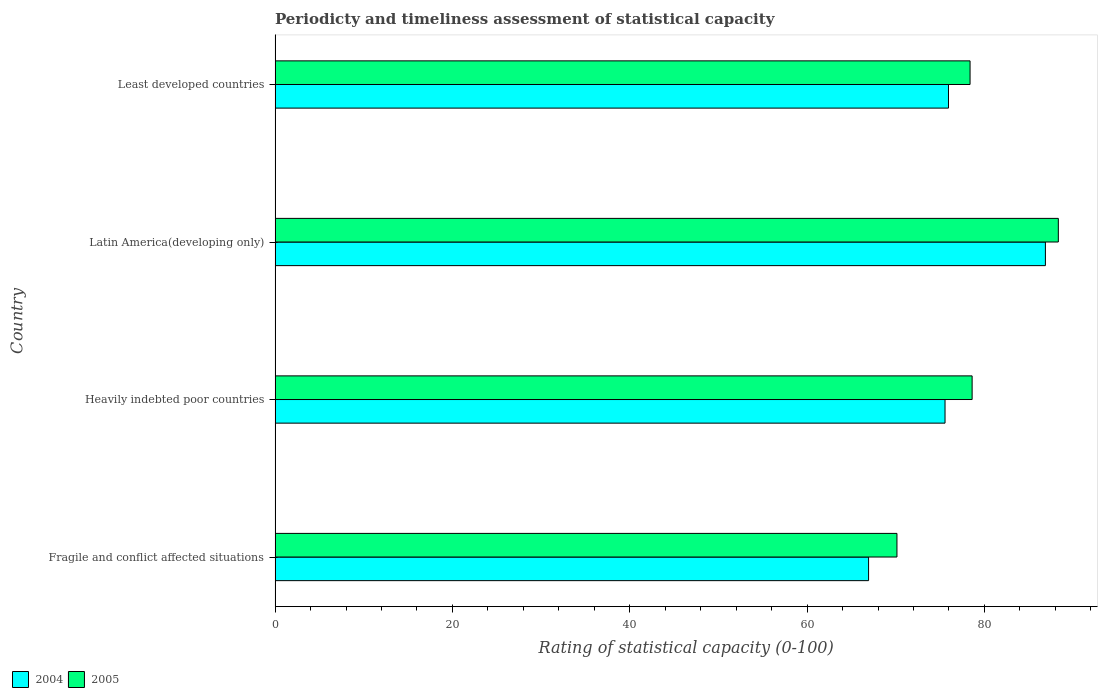How many different coloured bars are there?
Make the answer very short. 2. Are the number of bars on each tick of the Y-axis equal?
Ensure brevity in your answer.  Yes. What is the label of the 3rd group of bars from the top?
Make the answer very short. Heavily indebted poor countries. What is the rating of statistical capacity in 2004 in Fragile and conflict affected situations?
Your answer should be compact. 66.93. Across all countries, what is the maximum rating of statistical capacity in 2004?
Offer a terse response. 86.88. Across all countries, what is the minimum rating of statistical capacity in 2004?
Keep it short and to the point. 66.93. In which country was the rating of statistical capacity in 2005 maximum?
Keep it short and to the point. Latin America(developing only). In which country was the rating of statistical capacity in 2005 minimum?
Your response must be concise. Fragile and conflict affected situations. What is the total rating of statistical capacity in 2004 in the graph?
Your answer should be very brief. 305.31. What is the difference between the rating of statistical capacity in 2005 in Fragile and conflict affected situations and that in Latin America(developing only)?
Your answer should be very brief. -18.2. What is the difference between the rating of statistical capacity in 2005 in Least developed countries and the rating of statistical capacity in 2004 in Latin America(developing only)?
Give a very brief answer. -8.5. What is the average rating of statistical capacity in 2004 per country?
Provide a short and direct response. 76.33. What is the difference between the rating of statistical capacity in 2005 and rating of statistical capacity in 2004 in Fragile and conflict affected situations?
Ensure brevity in your answer.  3.2. What is the ratio of the rating of statistical capacity in 2005 in Fragile and conflict affected situations to that in Latin America(developing only)?
Provide a short and direct response. 0.79. Is the rating of statistical capacity in 2005 in Latin America(developing only) less than that in Least developed countries?
Provide a succinct answer. No. Is the difference between the rating of statistical capacity in 2005 in Fragile and conflict affected situations and Latin America(developing only) greater than the difference between the rating of statistical capacity in 2004 in Fragile and conflict affected situations and Latin America(developing only)?
Provide a short and direct response. Yes. What is the difference between the highest and the second highest rating of statistical capacity in 2004?
Your answer should be compact. 10.93. What is the difference between the highest and the lowest rating of statistical capacity in 2004?
Offer a very short reply. 19.94. Is the sum of the rating of statistical capacity in 2005 in Heavily indebted poor countries and Latin America(developing only) greater than the maximum rating of statistical capacity in 2004 across all countries?
Offer a terse response. Yes. What does the 1st bar from the bottom in Heavily indebted poor countries represents?
Offer a very short reply. 2004. How many countries are there in the graph?
Offer a terse response. 4. Does the graph contain any zero values?
Offer a terse response. No. Does the graph contain grids?
Provide a short and direct response. No. Where does the legend appear in the graph?
Offer a very short reply. Bottom left. What is the title of the graph?
Offer a terse response. Periodicty and timeliness assessment of statistical capacity. What is the label or title of the X-axis?
Offer a terse response. Rating of statistical capacity (0-100). What is the Rating of statistical capacity (0-100) of 2004 in Fragile and conflict affected situations?
Your answer should be compact. 66.93. What is the Rating of statistical capacity (0-100) in 2005 in Fragile and conflict affected situations?
Give a very brief answer. 70.13. What is the Rating of statistical capacity (0-100) in 2004 in Heavily indebted poor countries?
Offer a very short reply. 75.56. What is the Rating of statistical capacity (0-100) of 2005 in Heavily indebted poor countries?
Make the answer very short. 78.61. What is the Rating of statistical capacity (0-100) of 2004 in Latin America(developing only)?
Your answer should be compact. 86.88. What is the Rating of statistical capacity (0-100) in 2005 in Latin America(developing only)?
Your answer should be compact. 88.33. What is the Rating of statistical capacity (0-100) of 2004 in Least developed countries?
Provide a short and direct response. 75.95. What is the Rating of statistical capacity (0-100) of 2005 in Least developed countries?
Keep it short and to the point. 78.38. Across all countries, what is the maximum Rating of statistical capacity (0-100) in 2004?
Provide a succinct answer. 86.88. Across all countries, what is the maximum Rating of statistical capacity (0-100) in 2005?
Give a very brief answer. 88.33. Across all countries, what is the minimum Rating of statistical capacity (0-100) in 2004?
Give a very brief answer. 66.93. Across all countries, what is the minimum Rating of statistical capacity (0-100) in 2005?
Provide a succinct answer. 70.13. What is the total Rating of statistical capacity (0-100) of 2004 in the graph?
Provide a succinct answer. 305.31. What is the total Rating of statistical capacity (0-100) of 2005 in the graph?
Provide a succinct answer. 315.46. What is the difference between the Rating of statistical capacity (0-100) of 2004 in Fragile and conflict affected situations and that in Heavily indebted poor countries?
Provide a succinct answer. -8.62. What is the difference between the Rating of statistical capacity (0-100) in 2005 in Fragile and conflict affected situations and that in Heavily indebted poor countries?
Offer a terse response. -8.48. What is the difference between the Rating of statistical capacity (0-100) in 2004 in Fragile and conflict affected situations and that in Latin America(developing only)?
Provide a short and direct response. -19.94. What is the difference between the Rating of statistical capacity (0-100) of 2005 in Fragile and conflict affected situations and that in Latin America(developing only)?
Offer a very short reply. -18.2. What is the difference between the Rating of statistical capacity (0-100) in 2004 in Fragile and conflict affected situations and that in Least developed countries?
Your answer should be very brief. -9.01. What is the difference between the Rating of statistical capacity (0-100) in 2005 in Fragile and conflict affected situations and that in Least developed countries?
Provide a succinct answer. -8.24. What is the difference between the Rating of statistical capacity (0-100) in 2004 in Heavily indebted poor countries and that in Latin America(developing only)?
Make the answer very short. -11.32. What is the difference between the Rating of statistical capacity (0-100) of 2005 in Heavily indebted poor countries and that in Latin America(developing only)?
Your response must be concise. -9.72. What is the difference between the Rating of statistical capacity (0-100) of 2004 in Heavily indebted poor countries and that in Least developed countries?
Offer a terse response. -0.39. What is the difference between the Rating of statistical capacity (0-100) in 2005 in Heavily indebted poor countries and that in Least developed countries?
Provide a short and direct response. 0.23. What is the difference between the Rating of statistical capacity (0-100) in 2004 in Latin America(developing only) and that in Least developed countries?
Ensure brevity in your answer.  10.93. What is the difference between the Rating of statistical capacity (0-100) of 2005 in Latin America(developing only) and that in Least developed countries?
Keep it short and to the point. 9.96. What is the difference between the Rating of statistical capacity (0-100) of 2004 in Fragile and conflict affected situations and the Rating of statistical capacity (0-100) of 2005 in Heavily indebted poor countries?
Offer a very short reply. -11.68. What is the difference between the Rating of statistical capacity (0-100) of 2004 in Fragile and conflict affected situations and the Rating of statistical capacity (0-100) of 2005 in Latin America(developing only)?
Give a very brief answer. -21.4. What is the difference between the Rating of statistical capacity (0-100) of 2004 in Fragile and conflict affected situations and the Rating of statistical capacity (0-100) of 2005 in Least developed countries?
Make the answer very short. -11.45. What is the difference between the Rating of statistical capacity (0-100) of 2004 in Heavily indebted poor countries and the Rating of statistical capacity (0-100) of 2005 in Latin America(developing only)?
Keep it short and to the point. -12.78. What is the difference between the Rating of statistical capacity (0-100) in 2004 in Heavily indebted poor countries and the Rating of statistical capacity (0-100) in 2005 in Least developed countries?
Keep it short and to the point. -2.82. What is the difference between the Rating of statistical capacity (0-100) in 2004 in Latin America(developing only) and the Rating of statistical capacity (0-100) in 2005 in Least developed countries?
Offer a very short reply. 8.5. What is the average Rating of statistical capacity (0-100) of 2004 per country?
Your answer should be compact. 76.33. What is the average Rating of statistical capacity (0-100) of 2005 per country?
Your response must be concise. 78.86. What is the difference between the Rating of statistical capacity (0-100) in 2004 and Rating of statistical capacity (0-100) in 2005 in Heavily indebted poor countries?
Provide a short and direct response. -3.06. What is the difference between the Rating of statistical capacity (0-100) of 2004 and Rating of statistical capacity (0-100) of 2005 in Latin America(developing only)?
Offer a terse response. -1.46. What is the difference between the Rating of statistical capacity (0-100) of 2004 and Rating of statistical capacity (0-100) of 2005 in Least developed countries?
Ensure brevity in your answer.  -2.43. What is the ratio of the Rating of statistical capacity (0-100) of 2004 in Fragile and conflict affected situations to that in Heavily indebted poor countries?
Your response must be concise. 0.89. What is the ratio of the Rating of statistical capacity (0-100) in 2005 in Fragile and conflict affected situations to that in Heavily indebted poor countries?
Offer a very short reply. 0.89. What is the ratio of the Rating of statistical capacity (0-100) in 2004 in Fragile and conflict affected situations to that in Latin America(developing only)?
Give a very brief answer. 0.77. What is the ratio of the Rating of statistical capacity (0-100) in 2005 in Fragile and conflict affected situations to that in Latin America(developing only)?
Your answer should be very brief. 0.79. What is the ratio of the Rating of statistical capacity (0-100) in 2004 in Fragile and conflict affected situations to that in Least developed countries?
Your answer should be very brief. 0.88. What is the ratio of the Rating of statistical capacity (0-100) of 2005 in Fragile and conflict affected situations to that in Least developed countries?
Give a very brief answer. 0.89. What is the ratio of the Rating of statistical capacity (0-100) of 2004 in Heavily indebted poor countries to that in Latin America(developing only)?
Offer a very short reply. 0.87. What is the ratio of the Rating of statistical capacity (0-100) of 2005 in Heavily indebted poor countries to that in Latin America(developing only)?
Make the answer very short. 0.89. What is the ratio of the Rating of statistical capacity (0-100) of 2004 in Heavily indebted poor countries to that in Least developed countries?
Make the answer very short. 0.99. What is the ratio of the Rating of statistical capacity (0-100) in 2004 in Latin America(developing only) to that in Least developed countries?
Make the answer very short. 1.14. What is the ratio of the Rating of statistical capacity (0-100) in 2005 in Latin America(developing only) to that in Least developed countries?
Give a very brief answer. 1.13. What is the difference between the highest and the second highest Rating of statistical capacity (0-100) of 2004?
Keep it short and to the point. 10.93. What is the difference between the highest and the second highest Rating of statistical capacity (0-100) in 2005?
Give a very brief answer. 9.72. What is the difference between the highest and the lowest Rating of statistical capacity (0-100) in 2004?
Offer a terse response. 19.94. 